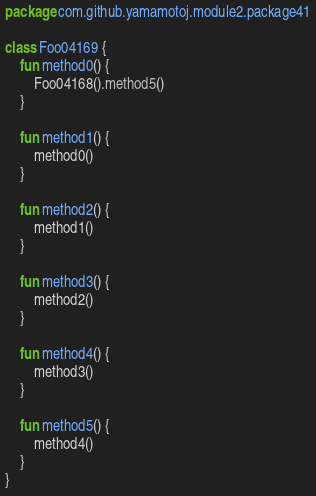<code> <loc_0><loc_0><loc_500><loc_500><_Kotlin_>package com.github.yamamotoj.module2.package41

class Foo04169 {
    fun method0() {
        Foo04168().method5()
    }

    fun method1() {
        method0()
    }

    fun method2() {
        method1()
    }

    fun method3() {
        method2()
    }

    fun method4() {
        method3()
    }

    fun method5() {
        method4()
    }
}
</code> 